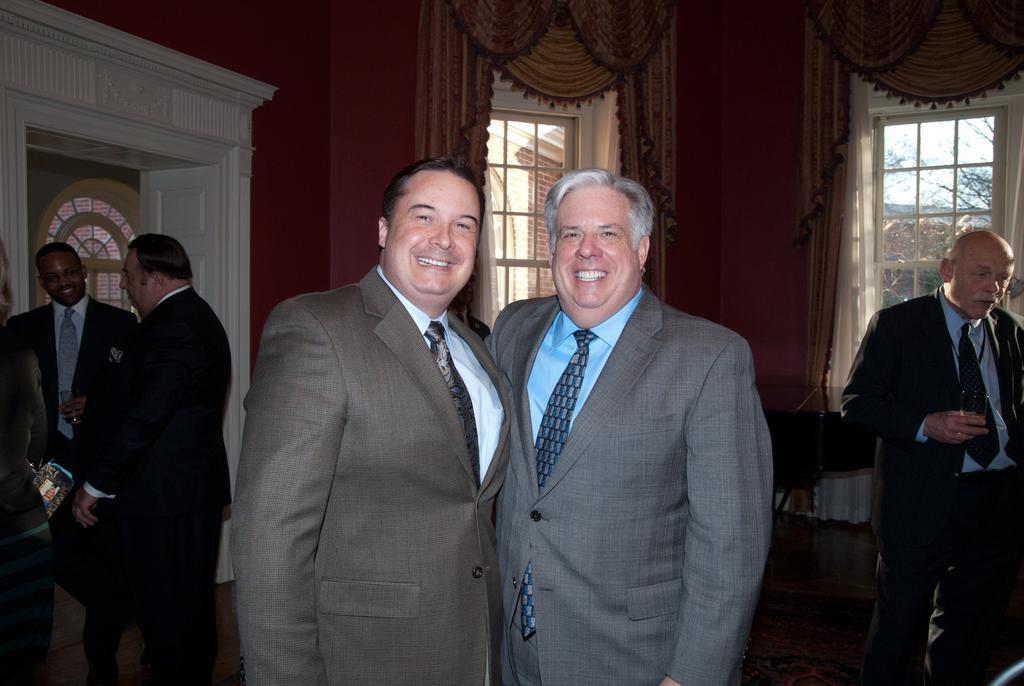Please provide a concise description of this image. In this image, at the middle there are two men standing and they are wearing coats and ties, they are smiling, at the right side there is an old man standing and he is holding a glass, at the left side there are some people standing, at the background there are some windows and curtains. 